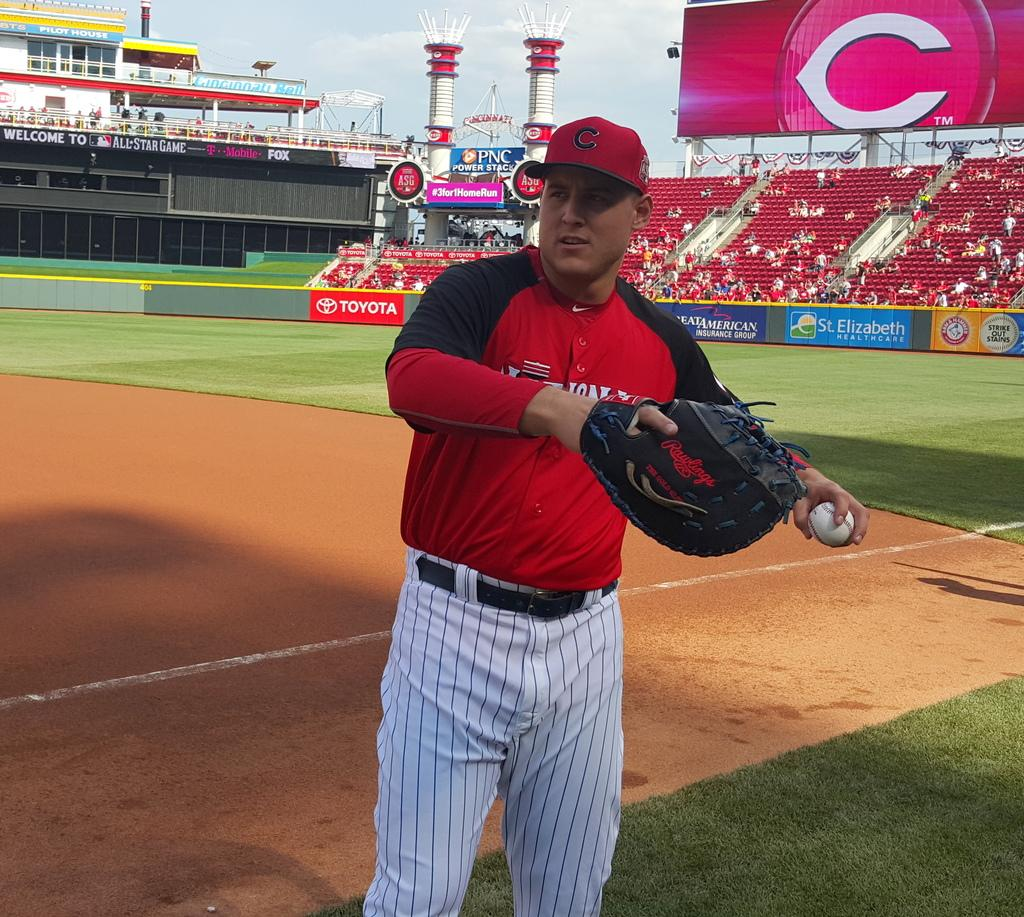<image>
Present a compact description of the photo's key features. A baseball player wearing a red jersey is about to throw the the ball and you can see a Toyota banner behind him. 